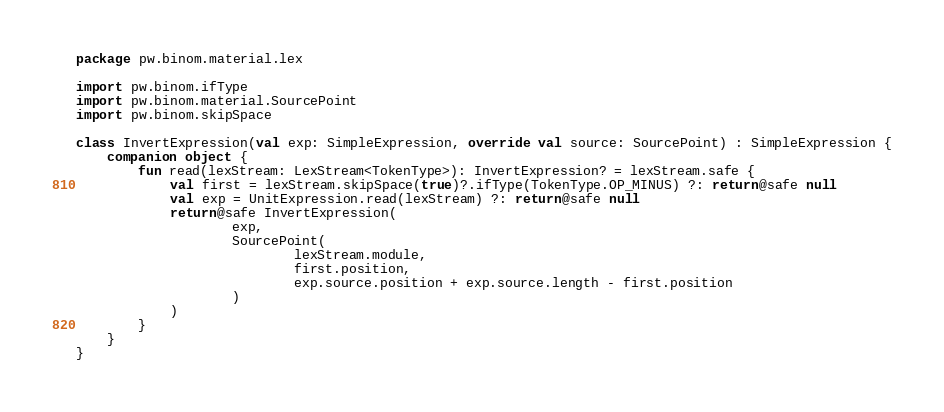<code> <loc_0><loc_0><loc_500><loc_500><_Kotlin_>package pw.binom.material.lex

import pw.binom.ifType
import pw.binom.material.SourcePoint
import pw.binom.skipSpace

class InvertExpression(val exp: SimpleExpression, override val source: SourcePoint) : SimpleExpression {
    companion object {
        fun read(lexStream: LexStream<TokenType>): InvertExpression? = lexStream.safe {
            val first = lexStream.skipSpace(true)?.ifType(TokenType.OP_MINUS) ?: return@safe null
            val exp = UnitExpression.read(lexStream) ?: return@safe null
            return@safe InvertExpression(
                    exp,
                    SourcePoint(
                            lexStream.module,
                            first.position,
                            exp.source.position + exp.source.length - first.position
                    )
            )
        }
    }
}</code> 